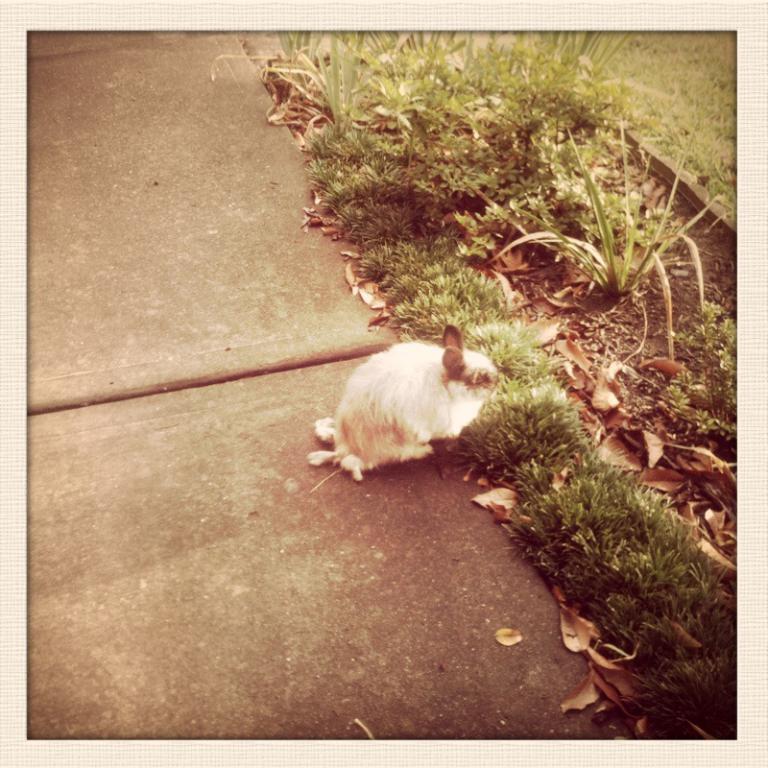How would you summarize this image in a sentence or two? In this image we can see a mammal on the surface and there are plants and grass on the ground. We can also see leaves on the ground. 